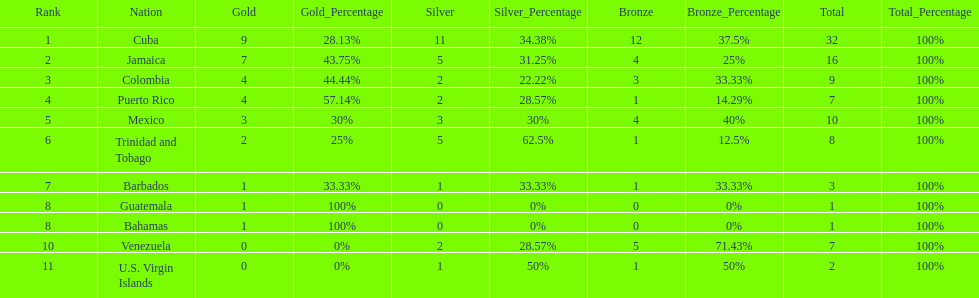The nation before mexico in the table Puerto Rico. 